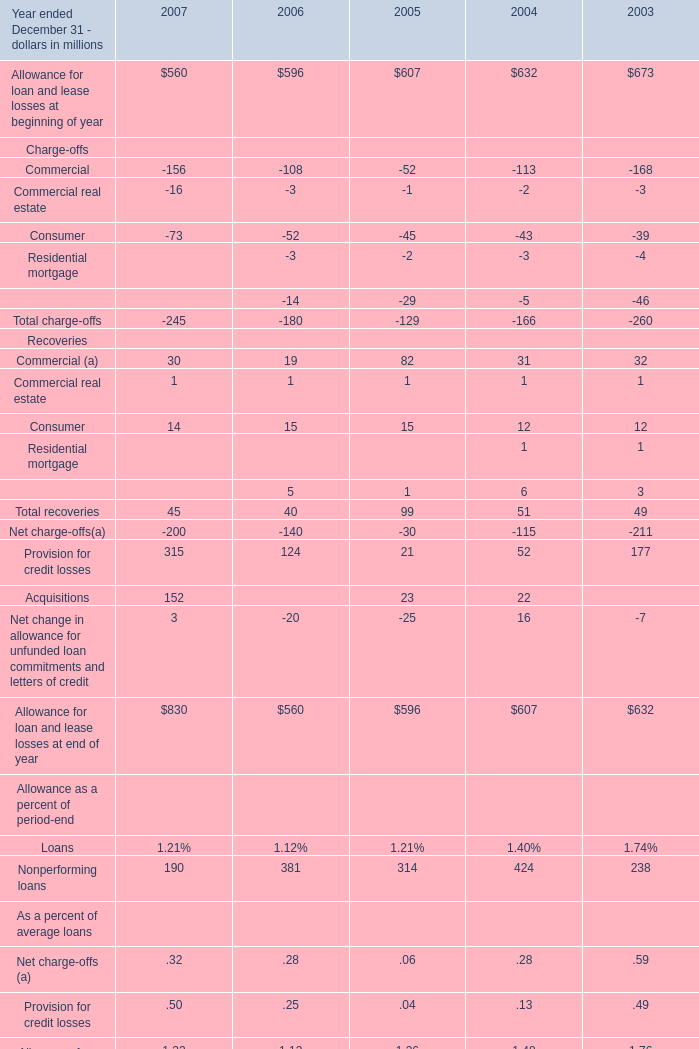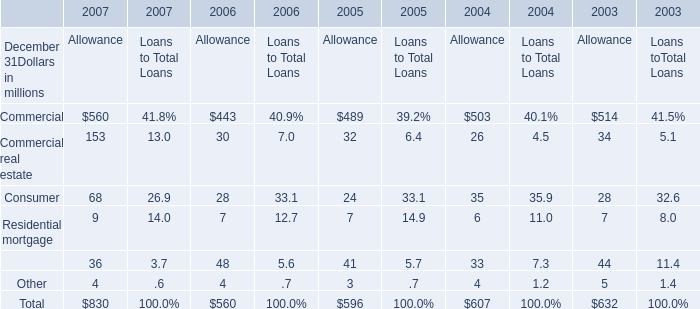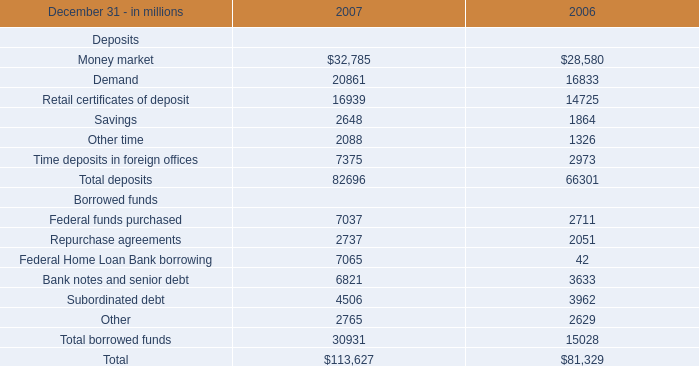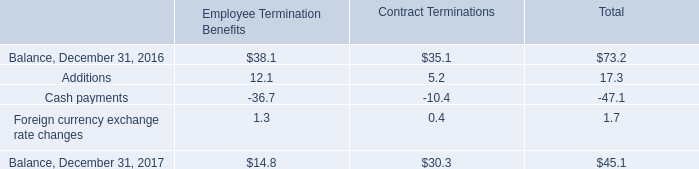Does the value of Allowance for loan and lease losses at beginning of year in 2007 greater than that in 2008? 
Answer: No. 